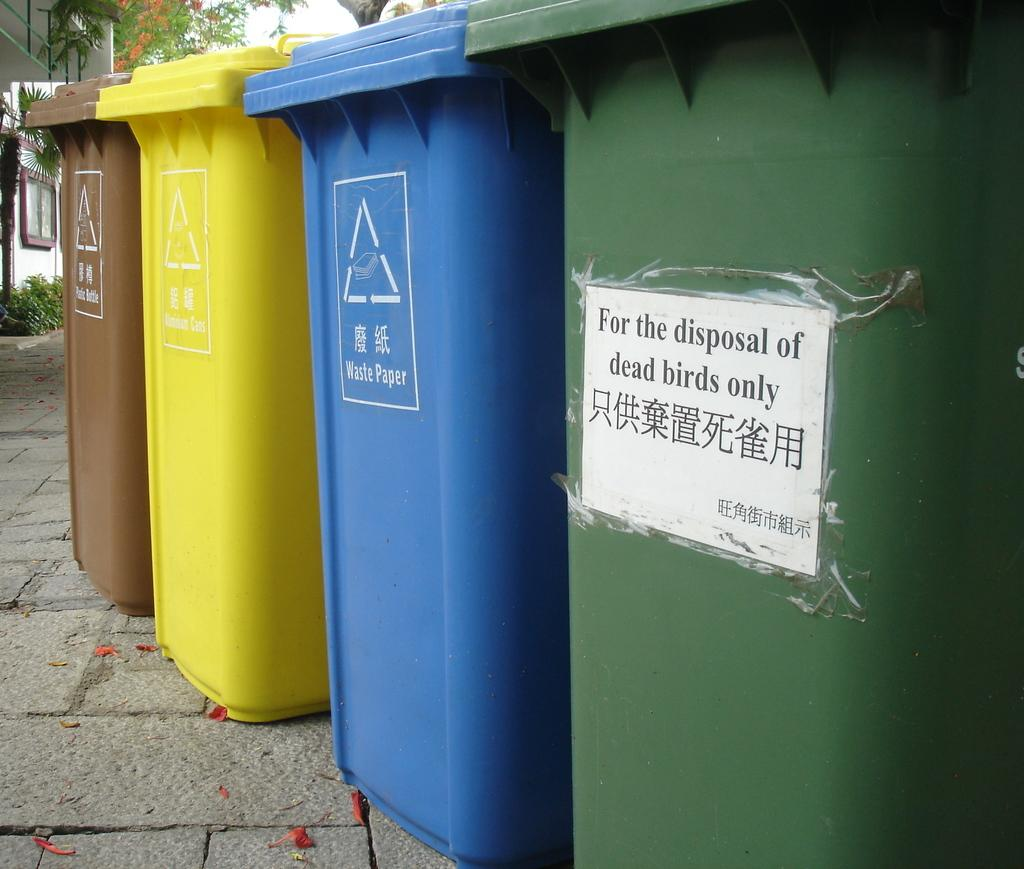<image>
Share a concise interpretation of the image provided. Colorful garbage bins with the green one saying "For the disposal of dead birds only". 